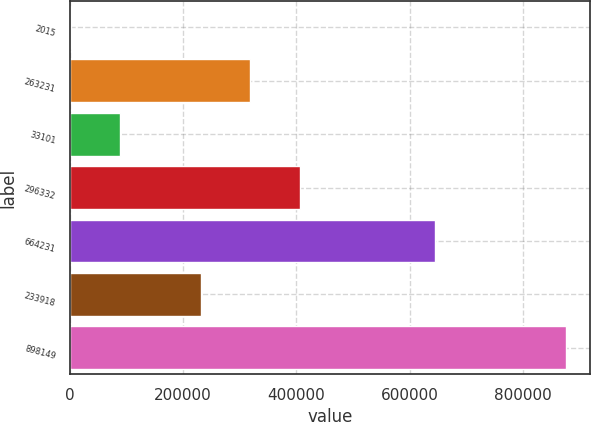Convert chart to OTSL. <chart><loc_0><loc_0><loc_500><loc_500><bar_chart><fcel>2015<fcel>263231<fcel>33101<fcel>296332<fcel>664231<fcel>233918<fcel>898149<nl><fcel>2014<fcel>318774<fcel>89353.3<fcel>406114<fcel>643972<fcel>231435<fcel>875407<nl></chart> 